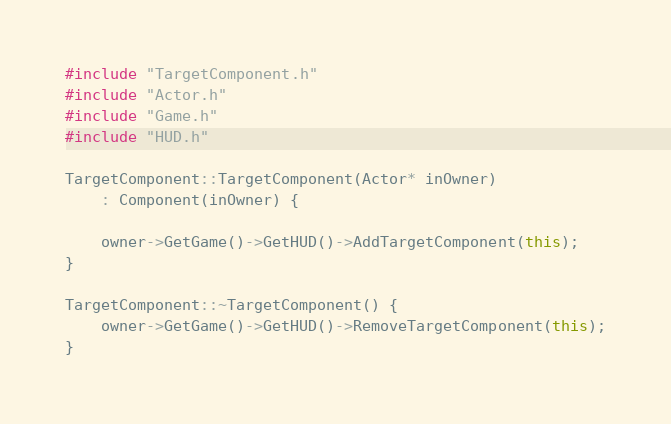Convert code to text. <code><loc_0><loc_0><loc_500><loc_500><_C++_>#include "TargetComponent.h"
#include "Actor.h"
#include "Game.h"
#include "HUD.h"

TargetComponent::TargetComponent(Actor* inOwner)
	: Component(inOwner) {

	owner->GetGame()->GetHUD()->AddTargetComponent(this);
}

TargetComponent::~TargetComponent() {
	owner->GetGame()->GetHUD()->RemoveTargetComponent(this);
}</code> 